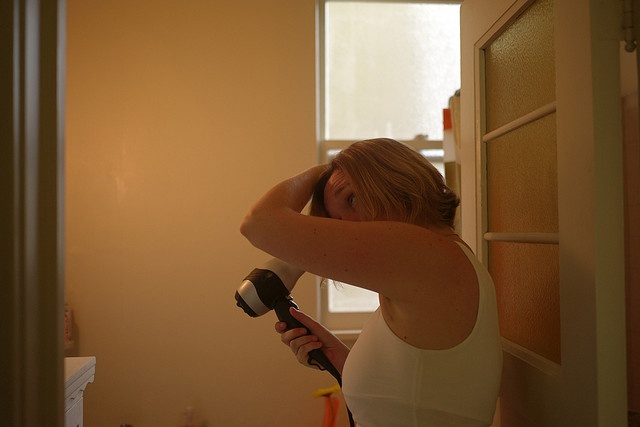Describe the objects in this image and their specific colors. I can see people in black, maroon, and gray tones and hair drier in black, maroon, and brown tones in this image. 